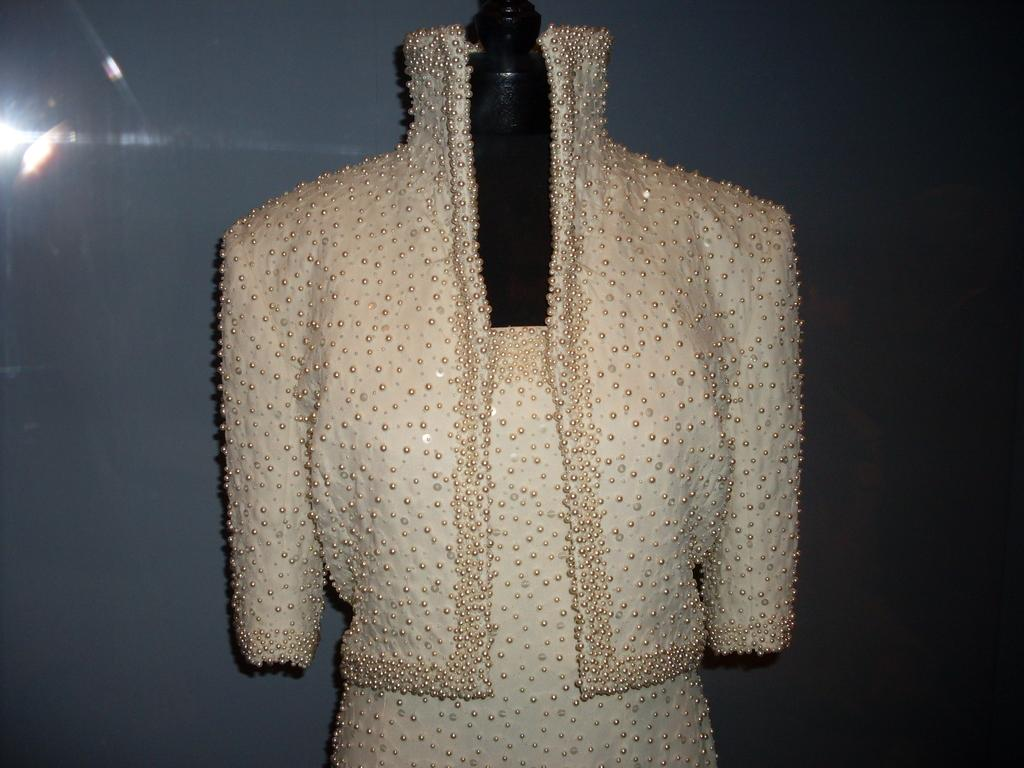What is displayed on the mannequin in the image? There is a dress on a mannequin in the image. What can be seen behind the mannequin? There is a wall visible in the image. Can you see any sea creatures swimming near the mannequin in the image? There is no sea or sea creatures present in the image; it features a dress on a mannequin and a wall. What type of engine is powering the mannequin in the image? There is no engine present in the image, as the mannequin is stationary and displaying a dress. 